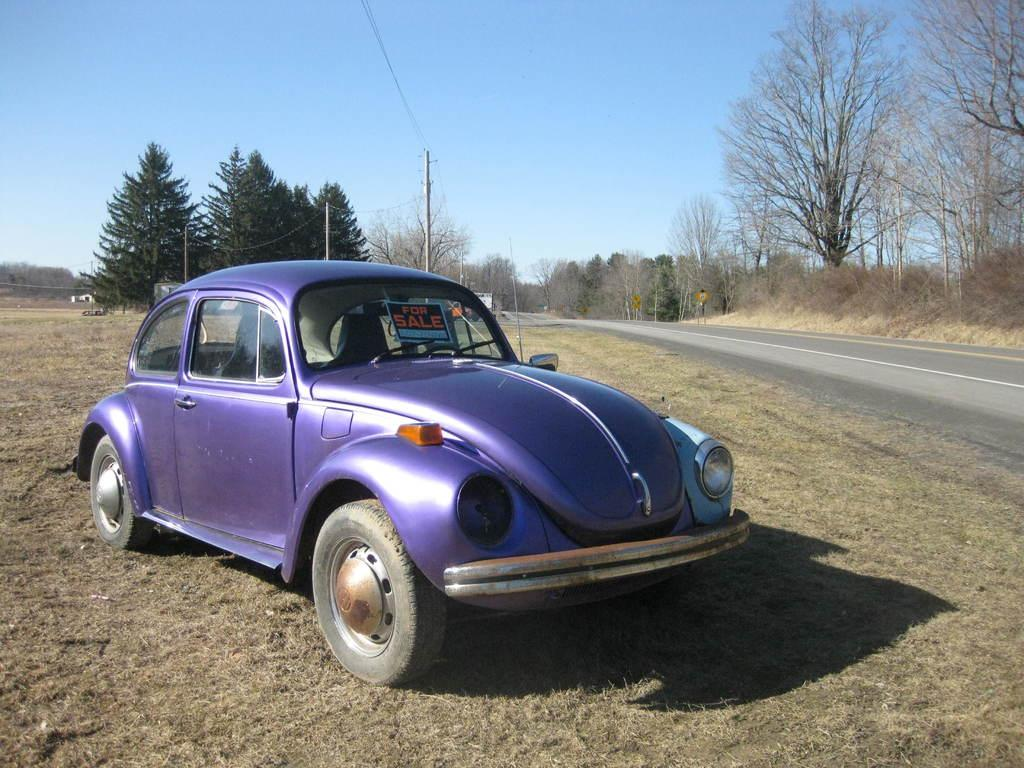What type of car is in the image? There is a purple classic car in the image. Where is the car located? The car is parked on the roadside. What can be seen behind the car? There are trees behind the car. What is on the right side of the image? There is a road on the right side of the image. What is the condition of the trees on the right side of the image? There are dry trees on the right side of the image. How many goldfish are swimming in the car's engine in the image? There are no goldfish present in the image, and they cannot be swimming in the car's engine. What type of quilt is covering the car in the image? There is no quilt covering the car in the image. 